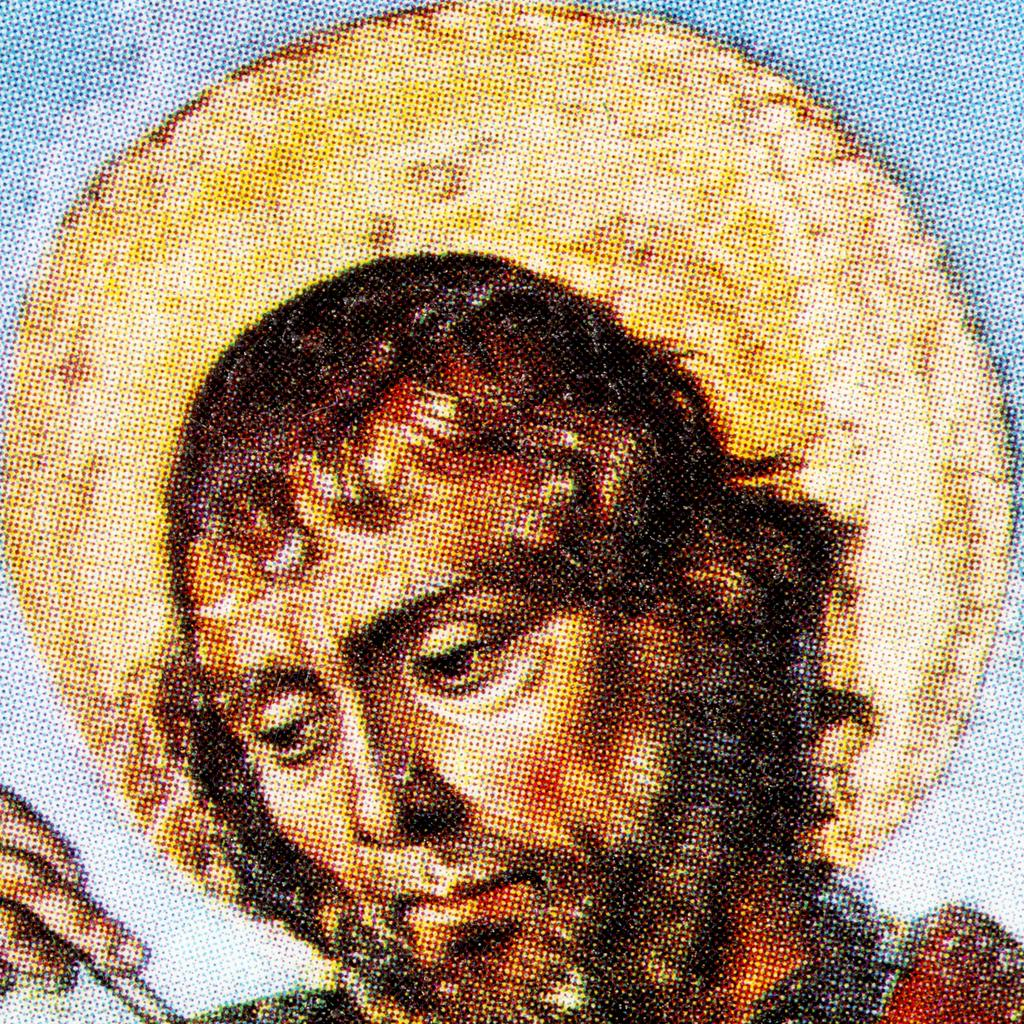What is the main subject of the image? There is a painting in the image. What is depicted in the painting? The painting depicts a person. What is the person in the painting doing? The person is holding an object in the painting. What type of alarm can be heard going off in the scene? There is no alarm present in the image, as it only features a painting of a person holding an object. 